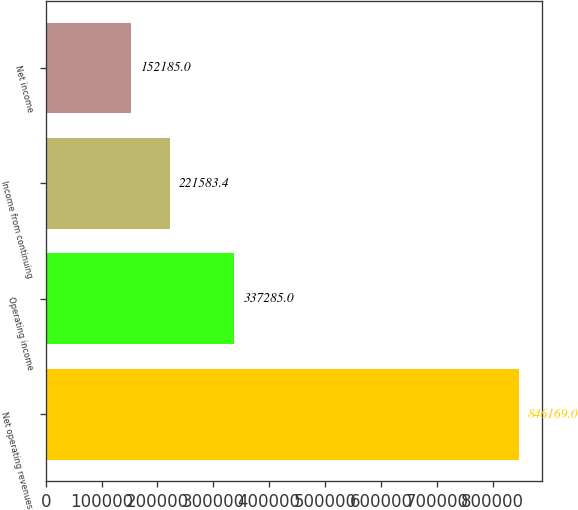Convert chart to OTSL. <chart><loc_0><loc_0><loc_500><loc_500><bar_chart><fcel>Net operating revenues<fcel>Operating income<fcel>Income from continuing<fcel>Net income<nl><fcel>846169<fcel>337285<fcel>221583<fcel>152185<nl></chart> 